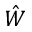<formula> <loc_0><loc_0><loc_500><loc_500>\hat { W }</formula> 